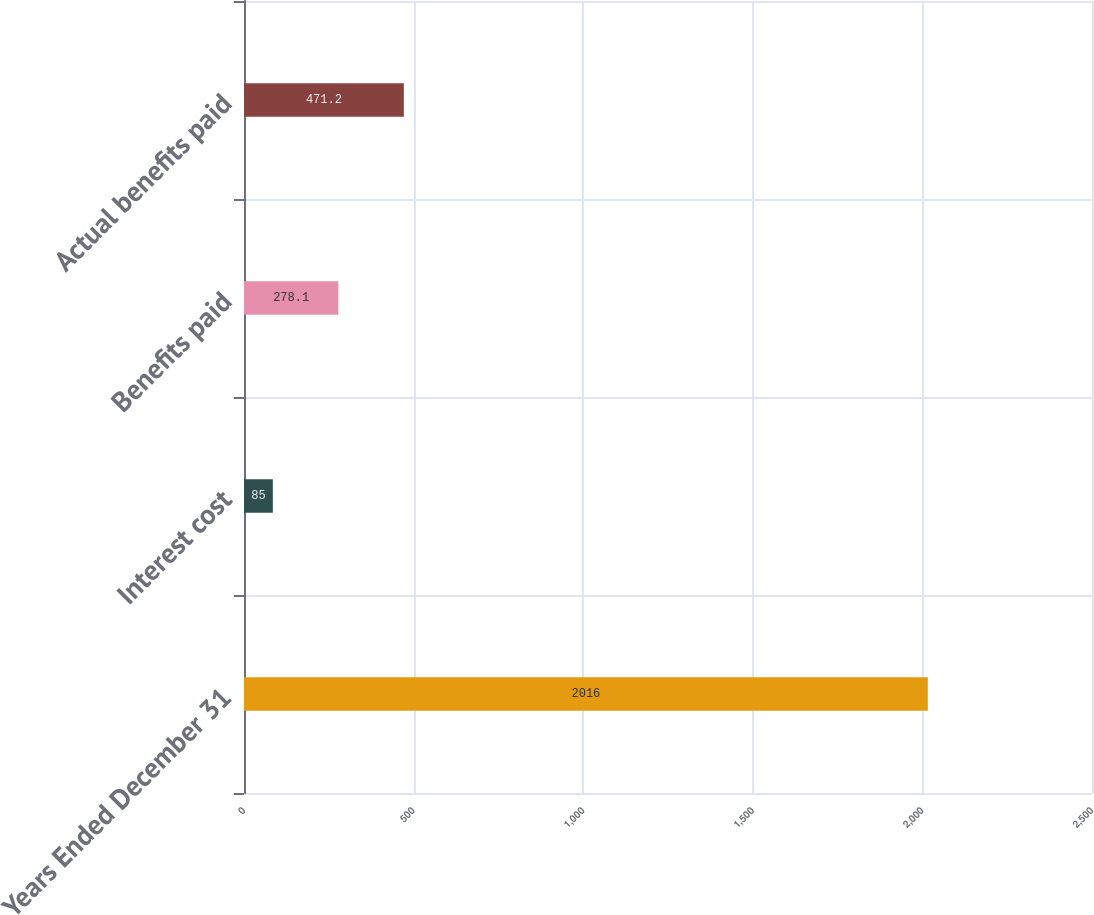Convert chart. <chart><loc_0><loc_0><loc_500><loc_500><bar_chart><fcel>Years Ended December 31<fcel>Interest cost<fcel>Benefits paid<fcel>Actual benefits paid<nl><fcel>2016<fcel>85<fcel>278.1<fcel>471.2<nl></chart> 